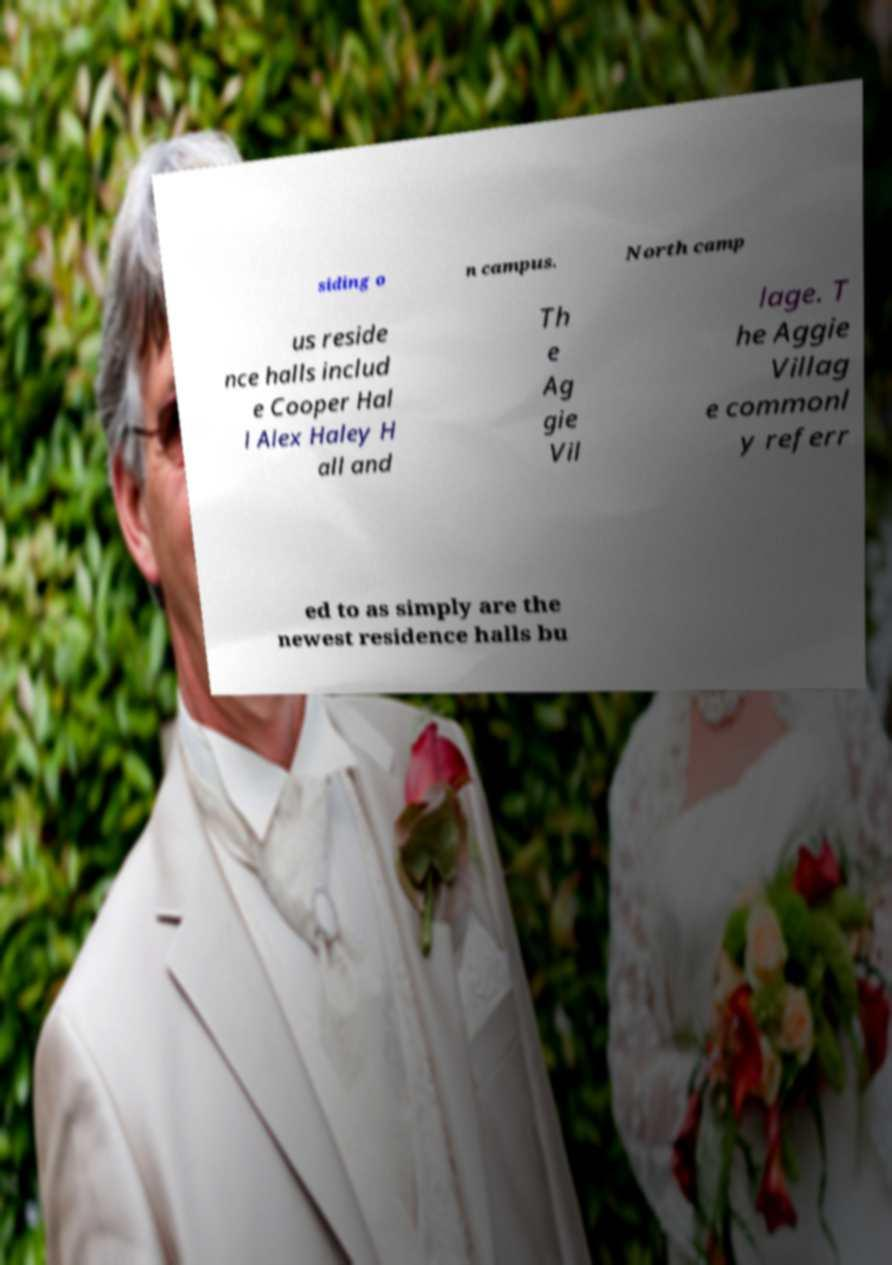What messages or text are displayed in this image? I need them in a readable, typed format. siding o n campus. North camp us reside nce halls includ e Cooper Hal l Alex Haley H all and Th e Ag gie Vil lage. T he Aggie Villag e commonl y referr ed to as simply are the newest residence halls bu 